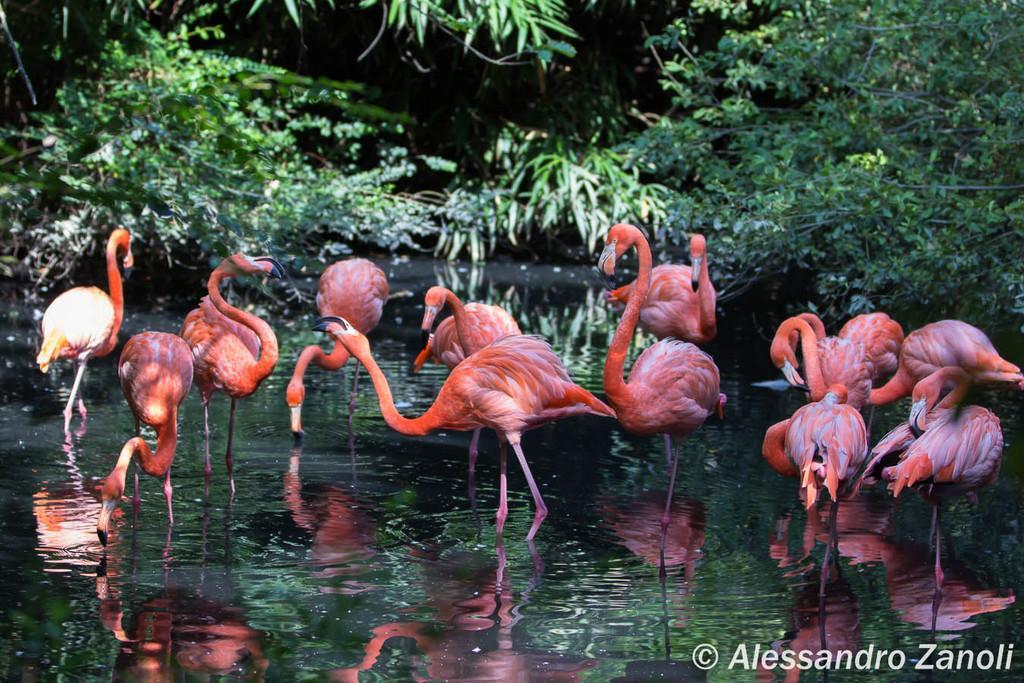Could you give a brief overview of what you see in this image? In this image I can see there is a water. In the water there are flamingo. And at the back there are trees. And there is a text written on the image. 